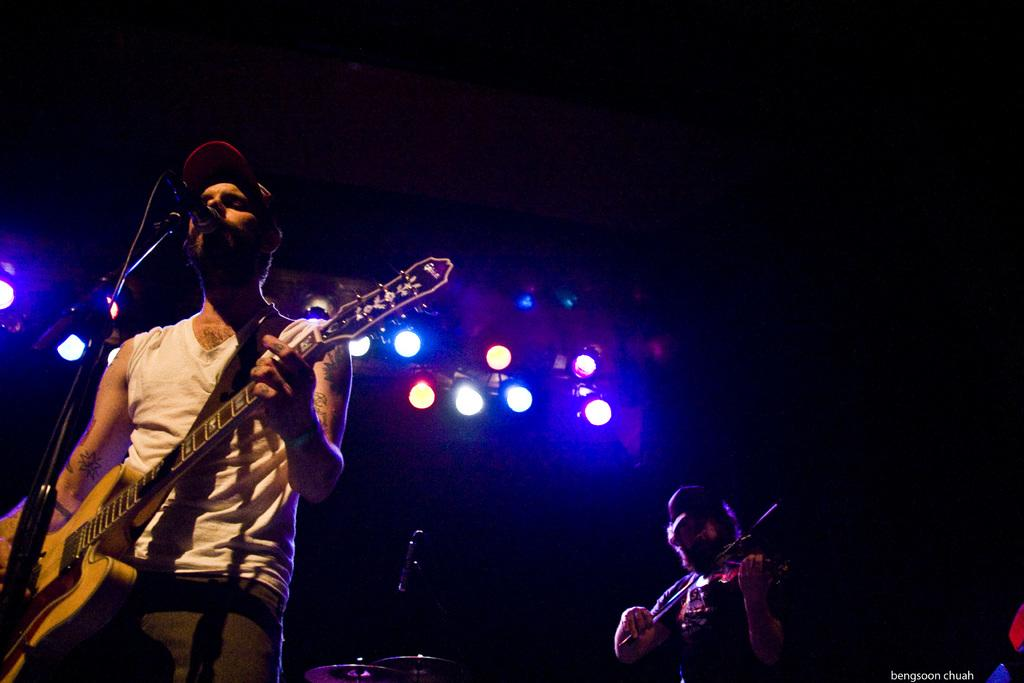What is the man in the image holding? The man is holding a guitar in his hand. Can you describe the other person in the image? There is another man in the image, and he is holding a violin in his hand. What might the two men be doing together? They might be playing music together, as they are both holding musical instruments. What is the topic of the argument between the two men in the image? There is no argument present in the image; the two men are holding musical instruments. How many additional people are present in the image, and what are they doing? There is no mention of any other people in the image besides the two men holding musical instruments. 